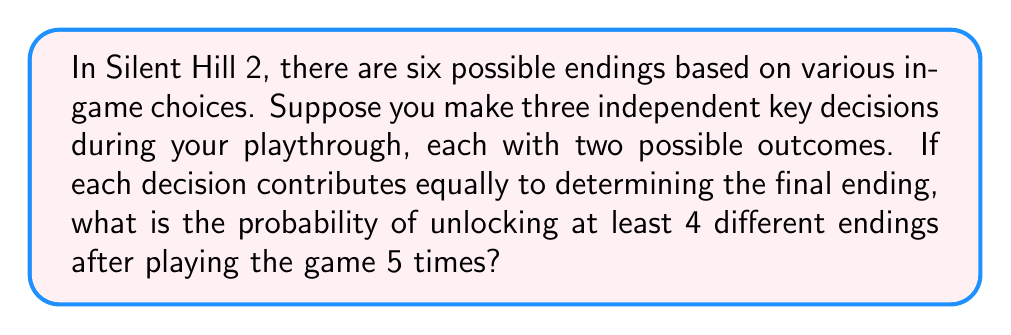Teach me how to tackle this problem. Let's approach this step-by-step:

1) First, we need to calculate the probability of getting a single ending:
   With 3 independent decisions, each with 2 outcomes, there are $2^3 = 8$ possible combinations.
   As there are 6 endings, we can assume each ending corresponds to at least 1 combination.
   So, the probability of getting any single ending is at least $\frac{1}{8}$.

2) The probability of not getting a specific ending in one playthrough is:
   $1 - \frac{1}{8} = \frac{7}{8}$

3) The probability of not getting a specific ending in 5 playthroughs is:
   $(\frac{7}{8})^5$

4) Therefore, the probability of getting a specific ending at least once in 5 playthroughs is:
   $1 - (\frac{7}{8})^5$

5) Now, we want the probability of getting at least 4 different endings. This is equivalent to the probability of not getting 3 or fewer endings.

6) We can use the binomial probability formula to calculate this:

   $P(X \geq 4) = 1 - P(X \leq 3)$

   Where $X$ is the number of different endings obtained.

7) $P(X \leq 3) = \binom{6}{0}(1-p)^6 + \binom{6}{1}p(1-p)^5 + \binom{6}{2}p^2(1-p)^4 + \binom{6}{3}p^3(1-p)^3$

   Where $p = 1 - (\frac{7}{8})^5$

8) Calculating this:
   $P(X \leq 3) \approx 0.2759$

9) Therefore, $P(X \geq 4) = 1 - 0.2759 \approx 0.7241$
Answer: The probability of unlocking at least 4 different endings after playing Silent Hill 2 five times is approximately 0.7241 or 72.41%. 